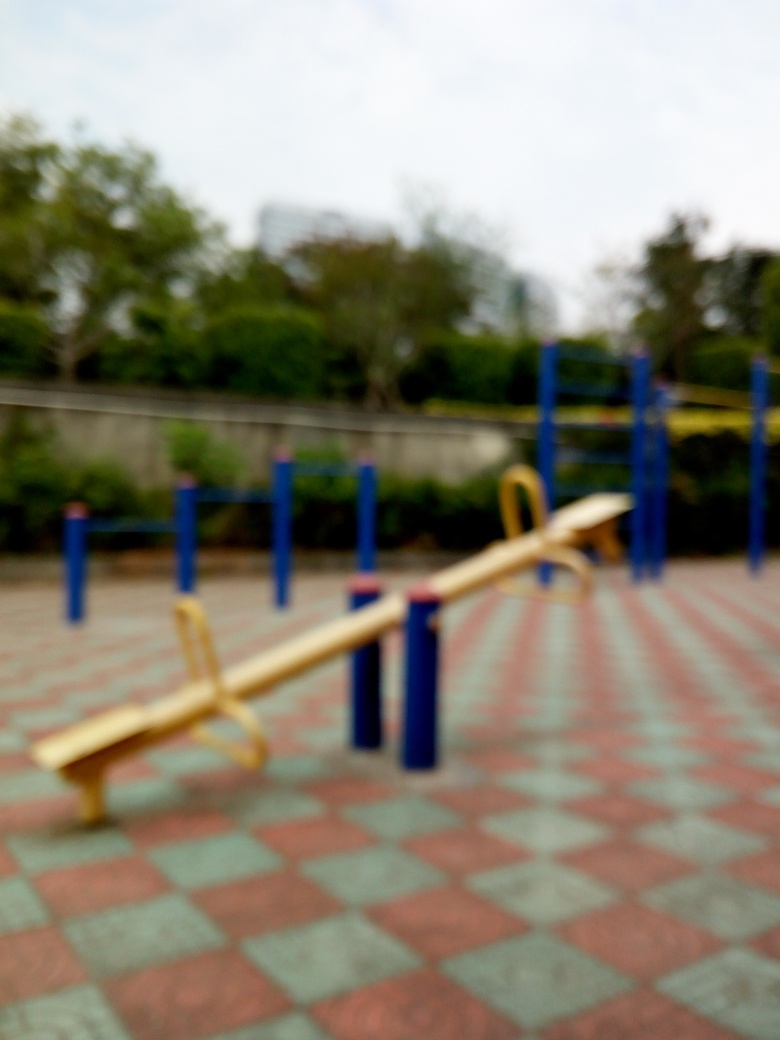What kind of maintenance would be required to keep this playground equipment in good condition? To keep playground equipment like this seesaw in good condition, regular maintenance is key. This includes checking for and repairing any wear or damage, such as rust on metal parts, cracks in plastic, and ensuring that moving parts are well lubricated. It's also important to clean the equipment regularly to remove dirt and debris, which can contribute to deterioration over time and ensure it remains hygienic for children to use. 